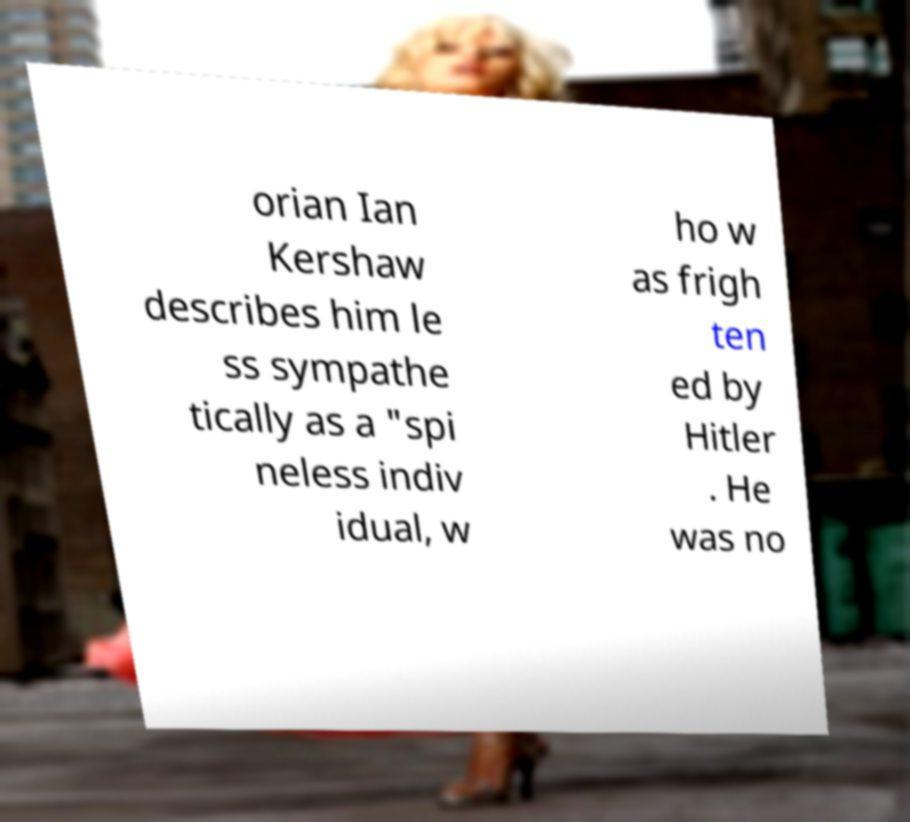I need the written content from this picture converted into text. Can you do that? orian Ian Kershaw describes him le ss sympathe tically as a "spi neless indiv idual, w ho w as frigh ten ed by Hitler . He was no 